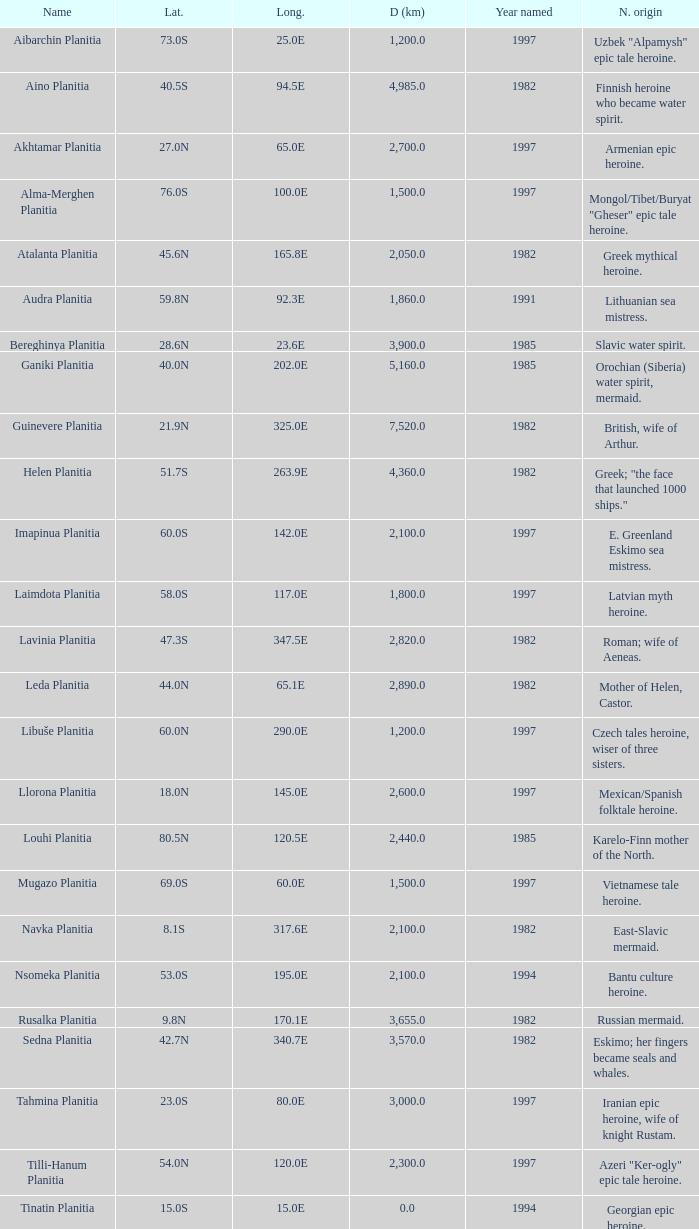What is the diameter (km) of feature of latitude 40.5s 4985.0. 